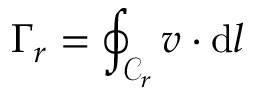Convert formula to latex. <formula><loc_0><loc_0><loc_500><loc_500>\Gamma _ { r } = \oint _ { \mathcal { C } _ { r } } v \cdot d l</formula> 